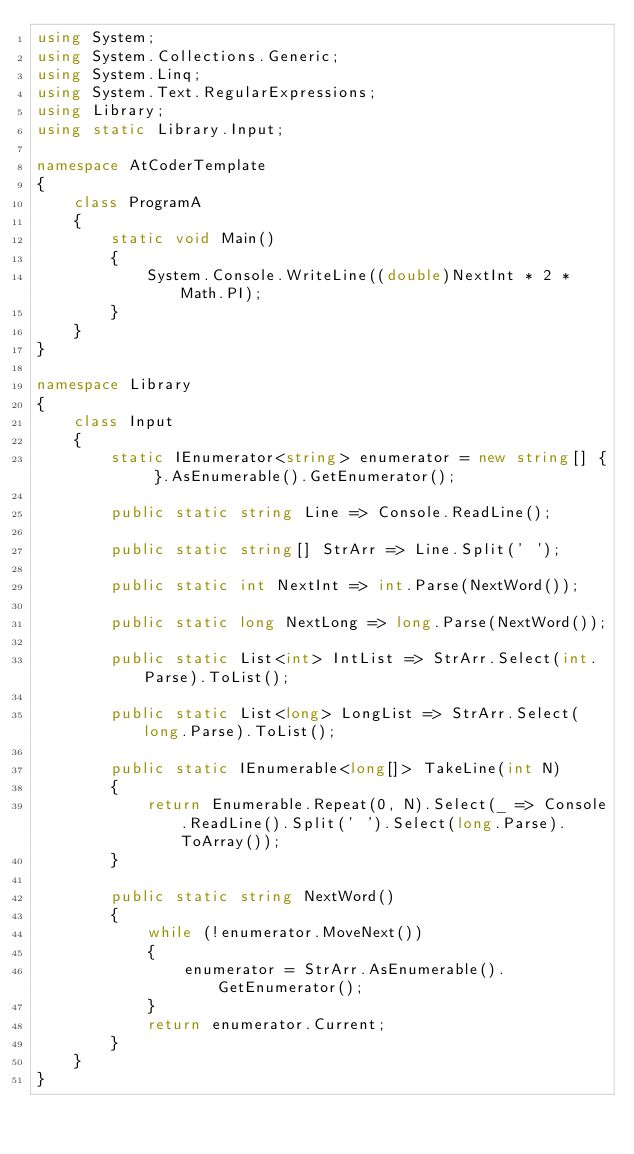Convert code to text. <code><loc_0><loc_0><loc_500><loc_500><_C#_>using System;
using System.Collections.Generic;
using System.Linq;
using System.Text.RegularExpressions;
using Library;
using static Library.Input;

namespace AtCoderTemplate
{
    class ProgramA
    {
        static void Main()
        {
            System.Console.WriteLine((double)NextInt * 2 * Math.PI);
        }
    }
}

namespace Library
{
    class Input
    {
        static IEnumerator<string> enumerator = new string[] { }.AsEnumerable().GetEnumerator();

        public static string Line => Console.ReadLine();

        public static string[] StrArr => Line.Split(' ');

        public static int NextInt => int.Parse(NextWord());

        public static long NextLong => long.Parse(NextWord());

        public static List<int> IntList => StrArr.Select(int.Parse).ToList();

        public static List<long> LongList => StrArr.Select(long.Parse).ToList();

        public static IEnumerable<long[]> TakeLine(int N)
        {
            return Enumerable.Repeat(0, N).Select(_ => Console.ReadLine().Split(' ').Select(long.Parse).ToArray());
        }

        public static string NextWord()
        {
            while (!enumerator.MoveNext())
            {
                enumerator = StrArr.AsEnumerable().GetEnumerator();
            }
            return enumerator.Current;
        }
    }
}
</code> 